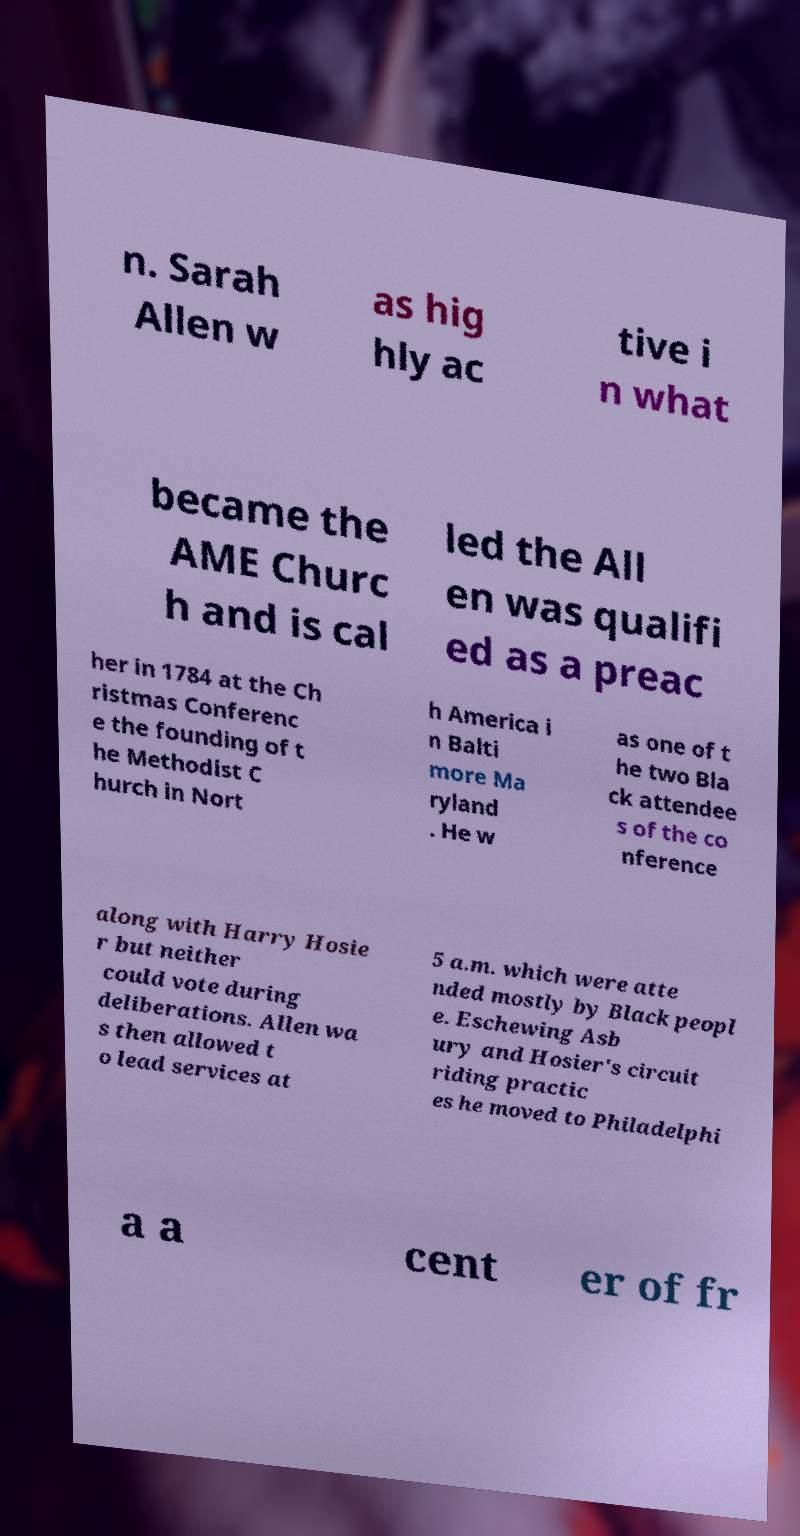What messages or text are displayed in this image? I need them in a readable, typed format. n. Sarah Allen w as hig hly ac tive i n what became the AME Churc h and is cal led the All en was qualifi ed as a preac her in 1784 at the Ch ristmas Conferenc e the founding of t he Methodist C hurch in Nort h America i n Balti more Ma ryland . He w as one of t he two Bla ck attendee s of the co nference along with Harry Hosie r but neither could vote during deliberations. Allen wa s then allowed t o lead services at 5 a.m. which were atte nded mostly by Black peopl e. Eschewing Asb ury and Hosier's circuit riding practic es he moved to Philadelphi a a cent er of fr 